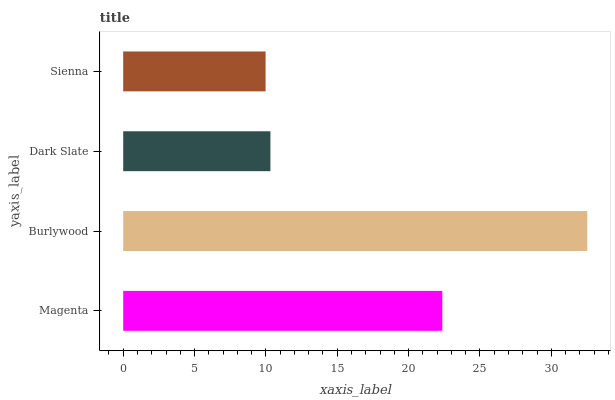Is Sienna the minimum?
Answer yes or no. Yes. Is Burlywood the maximum?
Answer yes or no. Yes. Is Dark Slate the minimum?
Answer yes or no. No. Is Dark Slate the maximum?
Answer yes or no. No. Is Burlywood greater than Dark Slate?
Answer yes or no. Yes. Is Dark Slate less than Burlywood?
Answer yes or no. Yes. Is Dark Slate greater than Burlywood?
Answer yes or no. No. Is Burlywood less than Dark Slate?
Answer yes or no. No. Is Magenta the high median?
Answer yes or no. Yes. Is Dark Slate the low median?
Answer yes or no. Yes. Is Dark Slate the high median?
Answer yes or no. No. Is Magenta the low median?
Answer yes or no. No. 